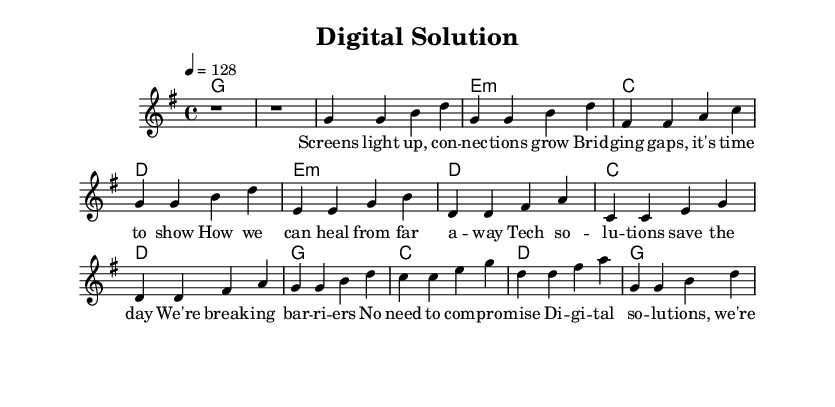What is the key signature of this music? The key signature is indicated at the beginning of the score, and it shows one sharp, which signifies that the piece is in G major.
Answer: G major What is the time signature of this piece? The time signature is shown at the beginning of the music, indicated as 4 over 4, meaning there are four beats per measure and a quarter note gets one beat.
Answer: 4/4 What is the tempo marking for the piece? The tempo marking is located above the staff, indicating the speed of the piece. It is set to 128 beats per minute, suggesting a moderately fast pace.
Answer: 128 How many measures are there in the verse section? To count the measures in the verse, we look at the melody for that section, which consists of four distinct groups of notes, each separated by a bar line. This gives us a total of four measures.
Answer: 4 What are the primary themes expressed in the lyrics? By analyzing the lyrics portion under the melody, we see that the themes focus on digital solutions, overcoming barriers, and efficiency, particularly through technology and connectivity.
Answer: Problem-solving and efficiency What is the chord progression used in the chorus? To determine the chord progression in the chorus, we refer to the harmony part during that section. The chords listed are G, C, D, and G, which outlines the harmonic structure.
Answer: G, C, D, G What stylistic elements classify this music as pop? The energetic tempo, catchy melodies, and thematic focus on problem-solving and efficiency align with the pop genre's characteristics, typically involving memorable hooks and relatable lyrics.
Answer: Energetic and catchy 